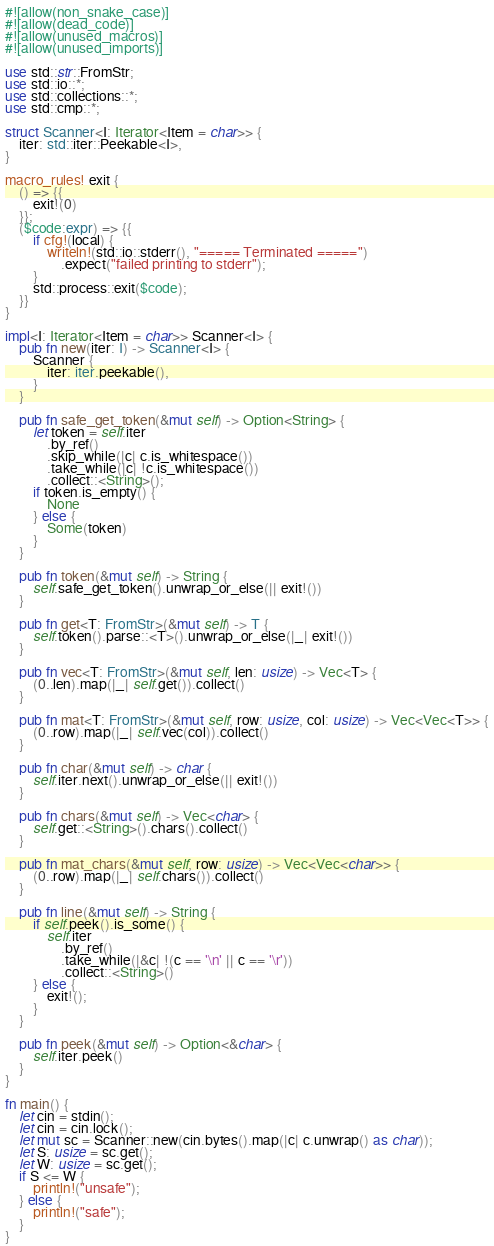Convert code to text. <code><loc_0><loc_0><loc_500><loc_500><_Rust_>#![allow(non_snake_case)]
#![allow(dead_code)]
#![allow(unused_macros)]
#![allow(unused_imports)]

use std::str::FromStr;
use std::io::*;
use std::collections::*;
use std::cmp::*;

struct Scanner<I: Iterator<Item = char>> {
    iter: std::iter::Peekable<I>,
}

macro_rules! exit {
    () => {{
        exit!(0)
    }};
    ($code:expr) => {{
        if cfg!(local) {
            writeln!(std::io::stderr(), "===== Terminated =====")
                .expect("failed printing to stderr");
        }
        std::process::exit($code);
    }}
}

impl<I: Iterator<Item = char>> Scanner<I> {
    pub fn new(iter: I) -> Scanner<I> {
        Scanner {
            iter: iter.peekable(),
        }
    }

    pub fn safe_get_token(&mut self) -> Option<String> {
        let token = self.iter
            .by_ref()
            .skip_while(|c| c.is_whitespace())
            .take_while(|c| !c.is_whitespace())
            .collect::<String>();
        if token.is_empty() {
            None
        } else {
            Some(token)
        }
    }

    pub fn token(&mut self) -> String {
        self.safe_get_token().unwrap_or_else(|| exit!())
    }

    pub fn get<T: FromStr>(&mut self) -> T {
        self.token().parse::<T>().unwrap_or_else(|_| exit!())
    }

    pub fn vec<T: FromStr>(&mut self, len: usize) -> Vec<T> {
        (0..len).map(|_| self.get()).collect()
    }

    pub fn mat<T: FromStr>(&mut self, row: usize, col: usize) -> Vec<Vec<T>> {
        (0..row).map(|_| self.vec(col)).collect()
    }

    pub fn char(&mut self) -> char {
        self.iter.next().unwrap_or_else(|| exit!())
    }

    pub fn chars(&mut self) -> Vec<char> {
        self.get::<String>().chars().collect()
    }

    pub fn mat_chars(&mut self, row: usize) -> Vec<Vec<char>> {
        (0..row).map(|_| self.chars()).collect()
    }

    pub fn line(&mut self) -> String {
        if self.peek().is_some() {
            self.iter
                .by_ref()
                .take_while(|&c| !(c == '\n' || c == '\r'))
                .collect::<String>()
        } else {
            exit!();
        }
    }

    pub fn peek(&mut self) -> Option<&char> {
        self.iter.peek()
    }
}

fn main() {
    let cin = stdin();
    let cin = cin.lock();
    let mut sc = Scanner::new(cin.bytes().map(|c| c.unwrap() as char));
    let S: usize = sc.get();
    let W: usize = sc.get();
    if S <= W {
        println!("unsafe");
    } else {
        println!("safe");
    }
}
</code> 